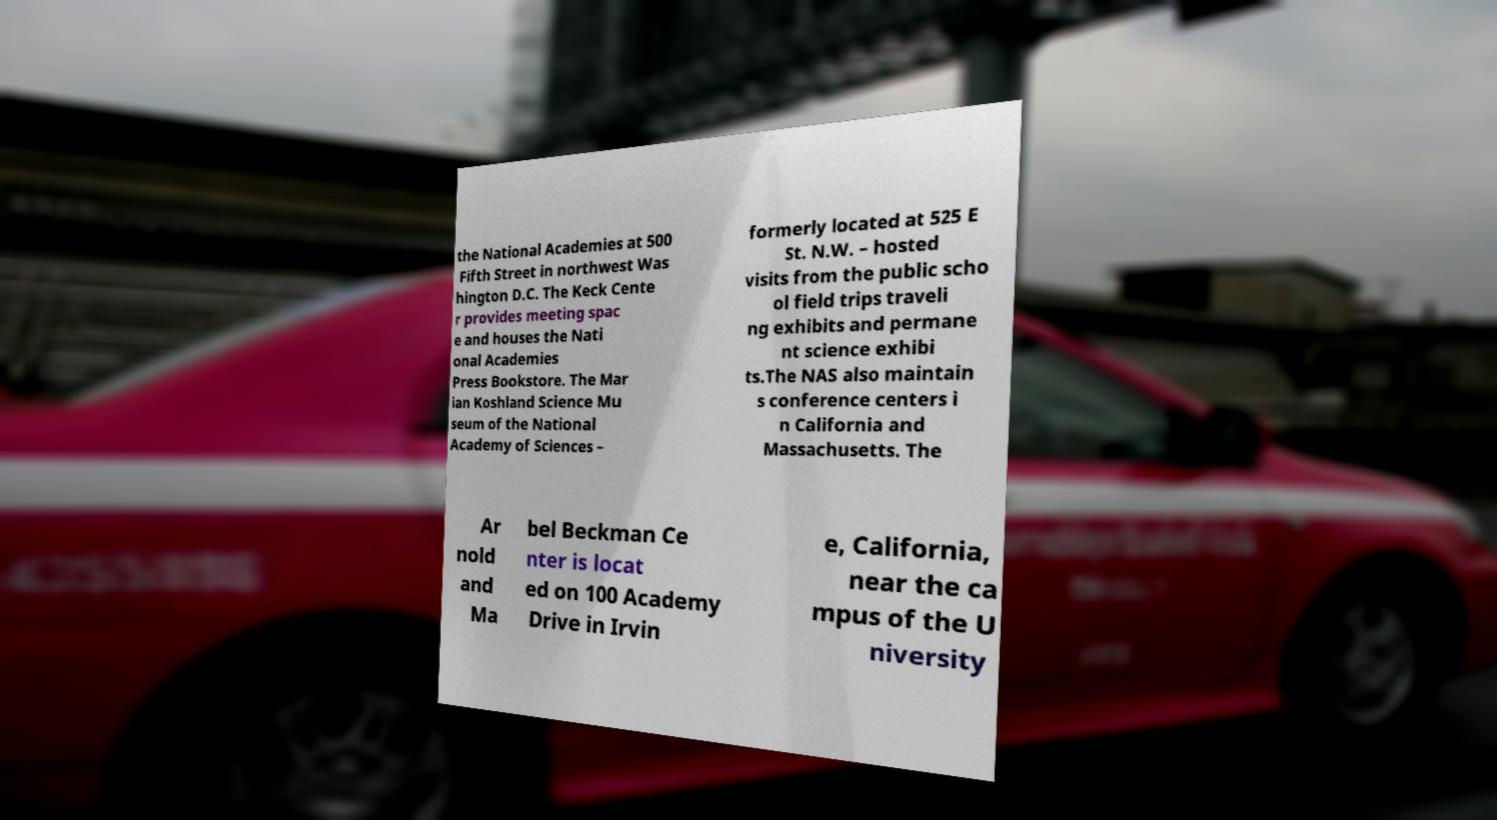Can you accurately transcribe the text from the provided image for me? the National Academies at 500 Fifth Street in northwest Was hington D.C. The Keck Cente r provides meeting spac e and houses the Nati onal Academies Press Bookstore. The Mar ian Koshland Science Mu seum of the National Academy of Sciences – formerly located at 525 E St. N.W. – hosted visits from the public scho ol field trips traveli ng exhibits and permane nt science exhibi ts.The NAS also maintain s conference centers i n California and Massachusetts. The Ar nold and Ma bel Beckman Ce nter is locat ed on 100 Academy Drive in Irvin e, California, near the ca mpus of the U niversity 